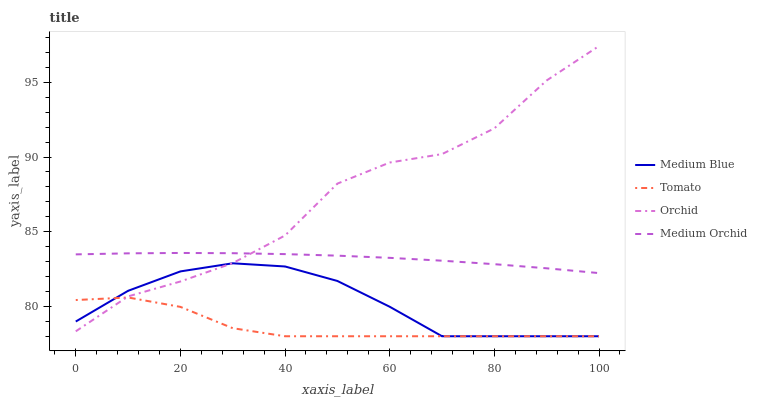Does Tomato have the minimum area under the curve?
Answer yes or no. Yes. Does Orchid have the maximum area under the curve?
Answer yes or no. Yes. Does Medium Orchid have the minimum area under the curve?
Answer yes or no. No. Does Medium Orchid have the maximum area under the curve?
Answer yes or no. No. Is Medium Orchid the smoothest?
Answer yes or no. Yes. Is Orchid the roughest?
Answer yes or no. Yes. Is Medium Blue the smoothest?
Answer yes or no. No. Is Medium Blue the roughest?
Answer yes or no. No. Does Tomato have the lowest value?
Answer yes or no. Yes. Does Medium Orchid have the lowest value?
Answer yes or no. No. Does Orchid have the highest value?
Answer yes or no. Yes. Does Medium Orchid have the highest value?
Answer yes or no. No. Is Tomato less than Medium Orchid?
Answer yes or no. Yes. Is Medium Orchid greater than Tomato?
Answer yes or no. Yes. Does Orchid intersect Medium Orchid?
Answer yes or no. Yes. Is Orchid less than Medium Orchid?
Answer yes or no. No. Is Orchid greater than Medium Orchid?
Answer yes or no. No. Does Tomato intersect Medium Orchid?
Answer yes or no. No. 